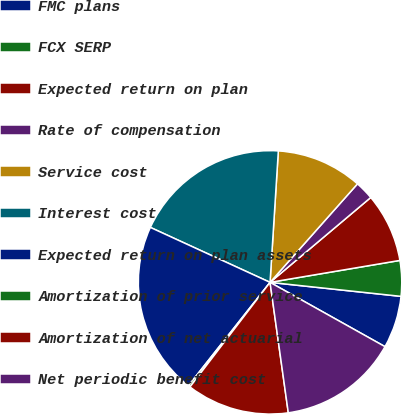<chart> <loc_0><loc_0><loc_500><loc_500><pie_chart><fcel>FMC plans<fcel>FCX SERP<fcel>Expected return on plan<fcel>Rate of compensation<fcel>Service cost<fcel>Interest cost<fcel>Expected return on plan assets<fcel>Amortization of prior service<fcel>Amortization of net actuarial<fcel>Net periodic benefit cost<nl><fcel>6.42%<fcel>4.36%<fcel>8.48%<fcel>2.3%<fcel>10.55%<fcel>19.15%<fcel>21.21%<fcel>0.24%<fcel>12.61%<fcel>14.67%<nl></chart> 